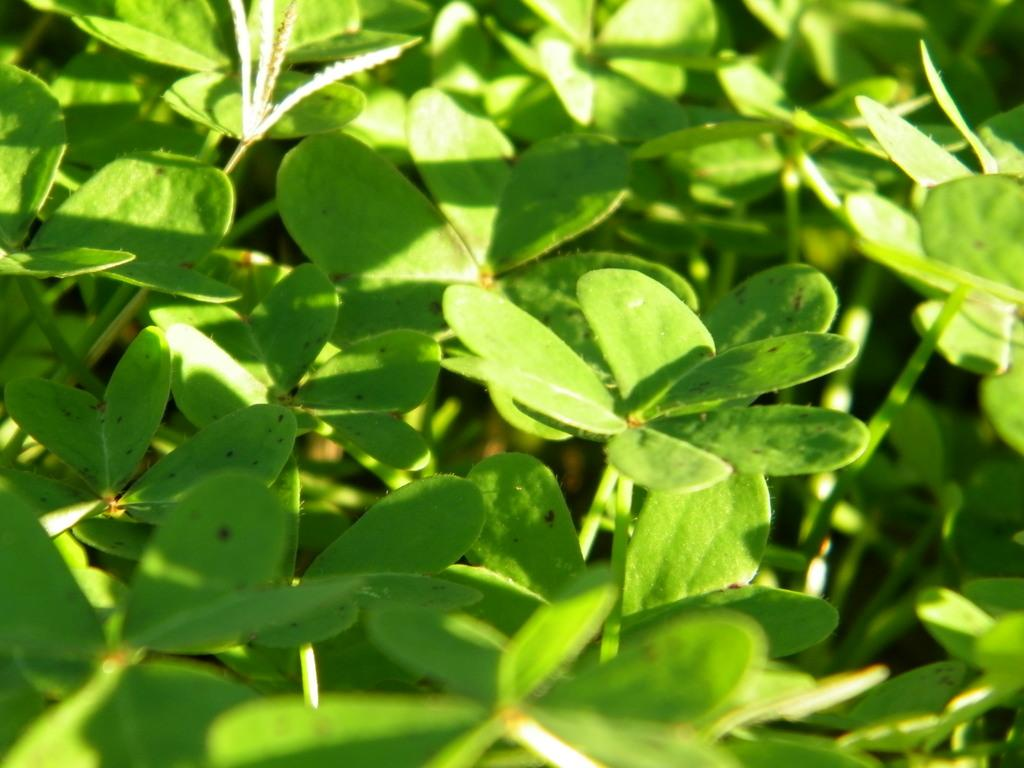What type of plants are visible in the image? There are green plants in the image. How many circles can be seen on the leaves of the plants in the image? There are no circles present on the leaves of the plants in the image. Are there any ladybugs crawling on the plants in the image? There is no mention of ladybugs in the provided facts, so we cannot determine if any are present in the image. 